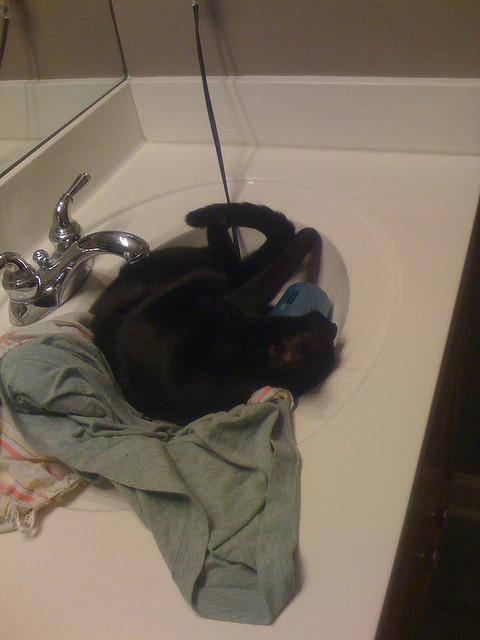Is the countertop cluttered?
Be succinct. Yes. What is the cat laying on?
Concise answer only. Sink. Is the kitten looking at the camera?
Answer briefly. No. Where was the cat seated?
Be succinct. Sink. What is the cat holding?
Keep it brief. Hair dryer. Where is this cat?
Concise answer only. In sink. Does the cat look amused?
Quick response, please. No. 